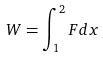Convert formula to latex. <formula><loc_0><loc_0><loc_500><loc_500>W = \int _ { 1 } ^ { 2 } F d x</formula> 